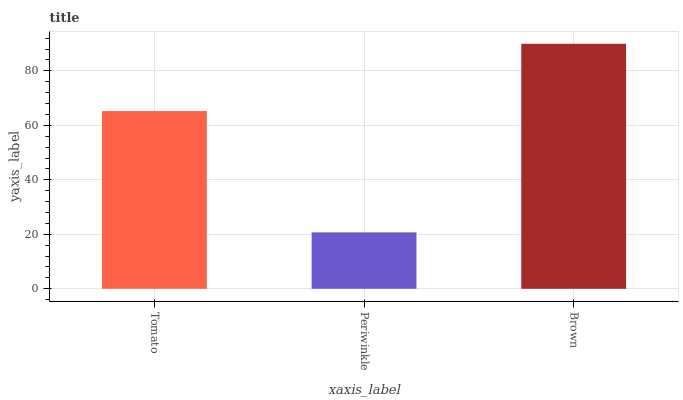Is Periwinkle the minimum?
Answer yes or no. Yes. Is Brown the maximum?
Answer yes or no. Yes. Is Brown the minimum?
Answer yes or no. No. Is Periwinkle the maximum?
Answer yes or no. No. Is Brown greater than Periwinkle?
Answer yes or no. Yes. Is Periwinkle less than Brown?
Answer yes or no. Yes. Is Periwinkle greater than Brown?
Answer yes or no. No. Is Brown less than Periwinkle?
Answer yes or no. No. Is Tomato the high median?
Answer yes or no. Yes. Is Tomato the low median?
Answer yes or no. Yes. Is Brown the high median?
Answer yes or no. No. Is Brown the low median?
Answer yes or no. No. 